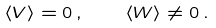Convert formula to latex. <formula><loc_0><loc_0><loc_500><loc_500>\langle V \rangle = 0 \, , \quad \langle W \rangle \ne 0 \, .</formula> 